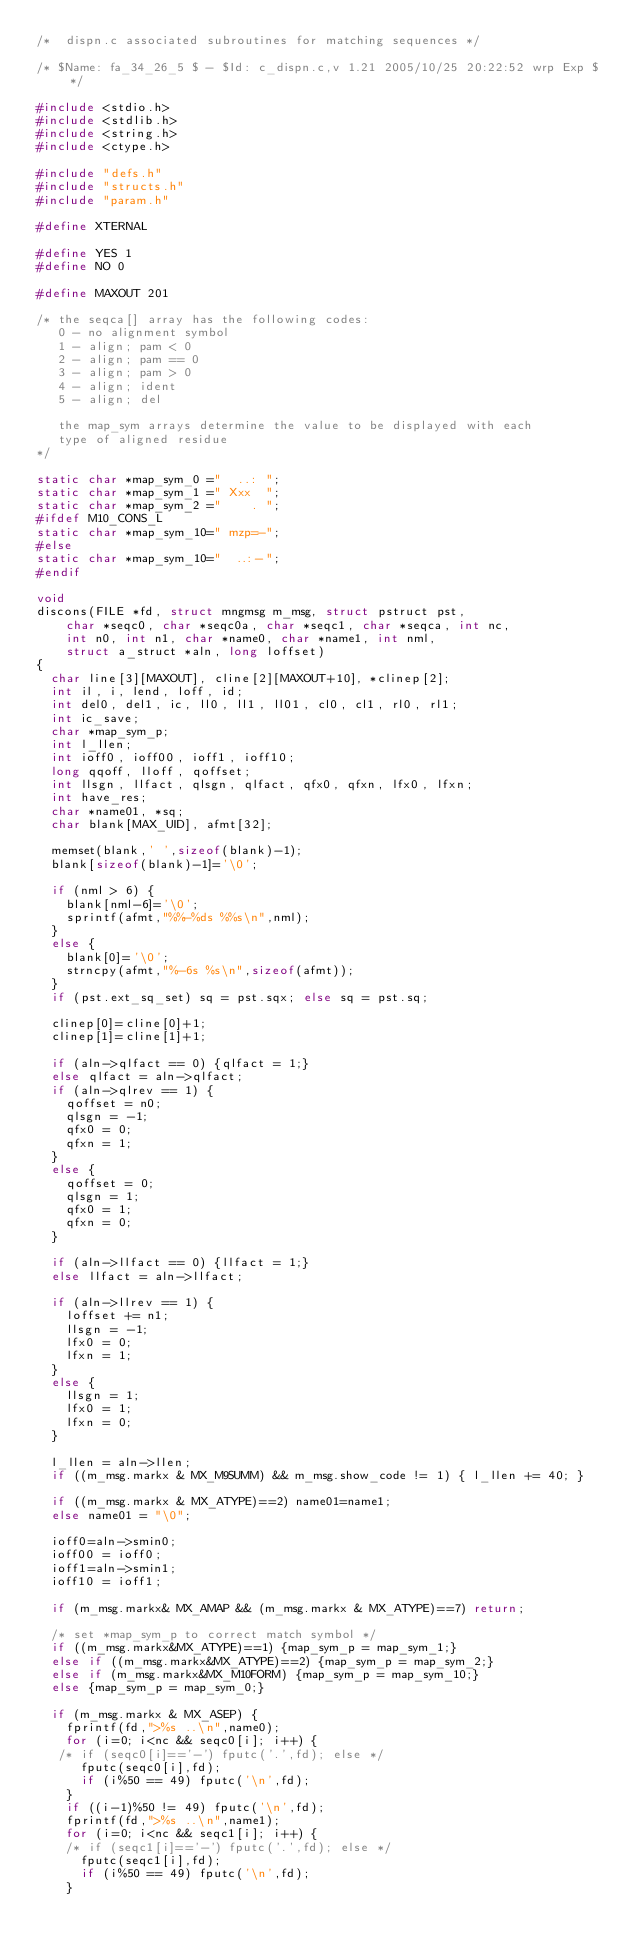Convert code to text. <code><loc_0><loc_0><loc_500><loc_500><_C_>/*	dispn.c	associated subroutines for matching sequences */

/* $Name: fa_34_26_5 $ - $Id: c_dispn.c,v 1.21 2005/10/25 20:22:52 wrp Exp $ */

#include <stdio.h>
#include <stdlib.h>
#include <string.h>
#include <ctype.h>

#include "defs.h"
#include "structs.h"
#include "param.h"

#define XTERNAL

#define YES 1
#define NO 0

#define MAXOUT 201

/* the seqca[] array has the following codes:
   0 - no alignment symbol
   1 - align; pam < 0
   2 - align; pam == 0
   3 - align; pam > 0
   4 - align; ident
   5 - align; del

   the map_sym arrays determine the value to be displayed with each
   type of aligned residue
*/

static char *map_sym_0 ="  ..: ";
static char *map_sym_1 =" Xxx  ";
static char *map_sym_2 ="    . ";
#ifdef M10_CONS_L
static char *map_sym_10=" mzp=-";
#else
static char *map_sym_10="  ..:-";
#endif

void
discons(FILE *fd, struct mngmsg m_msg, struct pstruct pst,
	char *seqc0, char *seqc0a, char *seqc1, char *seqca, int nc,
	int n0, int n1, char *name0, char *name1, int nml,
	struct a_struct *aln, long loffset)
{
  char line[3][MAXOUT], cline[2][MAXOUT+10], *clinep[2];
  int il, i, lend, loff, id;
  int del0, del1, ic, ll0, ll1, ll01, cl0, cl1, rl0, rl1;
  int ic_save;
  char *map_sym_p;
  int l_llen;
  int ioff0, ioff00, ioff1, ioff10;
  long qqoff, lloff, qoffset;
  int llsgn, llfact, qlsgn, qlfact, qfx0, qfxn, lfx0, lfxn;
  int have_res;
  char *name01, *sq;
  char blank[MAX_UID], afmt[32];

  memset(blank,' ',sizeof(blank)-1);
  blank[sizeof(blank)-1]='\0';

  if (nml > 6) {
    blank[nml-6]='\0';
    sprintf(afmt,"%%-%ds %%s\n",nml);
  }
  else {
    blank[0]='\0';
    strncpy(afmt,"%-6s %s\n",sizeof(afmt));
  }
  if (pst.ext_sq_set) sq = pst.sqx; else sq = pst.sq;

  clinep[0]=cline[0]+1;
  clinep[1]=cline[1]+1;

  if (aln->qlfact == 0) {qlfact = 1;}
  else qlfact = aln->qlfact;
  if (aln->qlrev == 1) {
    qoffset = n0;
    qlsgn = -1;
    qfx0 = 0;
    qfxn = 1;
  }
  else {
    qoffset = 0;
    qlsgn = 1;
    qfx0 = 1;
    qfxn = 0;
  }

  if (aln->llfact == 0) {llfact = 1;}
  else llfact = aln->llfact;

  if (aln->llrev == 1) {
    loffset += n1;
    llsgn = -1;
    lfx0 = 0;
    lfxn = 1;
  }
  else {
    llsgn = 1;
    lfx0 = 1;
    lfxn = 0;
  }

  l_llen = aln->llen;
  if ((m_msg.markx & MX_M9SUMM) && m_msg.show_code != 1) { l_llen += 40; }

  if ((m_msg.markx & MX_ATYPE)==2) name01=name1;
  else name01 = "\0";

  ioff0=aln->smin0;
  ioff00 = ioff0;
  ioff1=aln->smin1;
  ioff10 = ioff1;
  
  if (m_msg.markx& MX_AMAP && (m_msg.markx & MX_ATYPE)==7) return;

  /* set *map_sym_p to correct match symbol */
  if ((m_msg.markx&MX_ATYPE)==1) {map_sym_p = map_sym_1;}
  else if ((m_msg.markx&MX_ATYPE)==2) {map_sym_p = map_sym_2;}
  else if (m_msg.markx&MX_M10FORM) {map_sym_p = map_sym_10;}
  else {map_sym_p = map_sym_0;}

  if (m_msg.markx & MX_ASEP) {
    fprintf(fd,">%s ..\n",name0);
    for (i=0; i<nc && seqc0[i]; i++) {
   /* if (seqc0[i]=='-') fputc('.',fd); else */
      fputc(seqc0[i],fd);
      if (i%50 == 49) fputc('\n',fd);
    }
    if ((i-1)%50 != 49) fputc('\n',fd);
    fprintf(fd,">%s ..\n",name1);
    for (i=0; i<nc && seqc1[i]; i++) {
    /* if (seqc1[i]=='-') fputc('.',fd); else */
      fputc(seqc1[i],fd);
      if (i%50 == 49) fputc('\n',fd);
    }</code> 